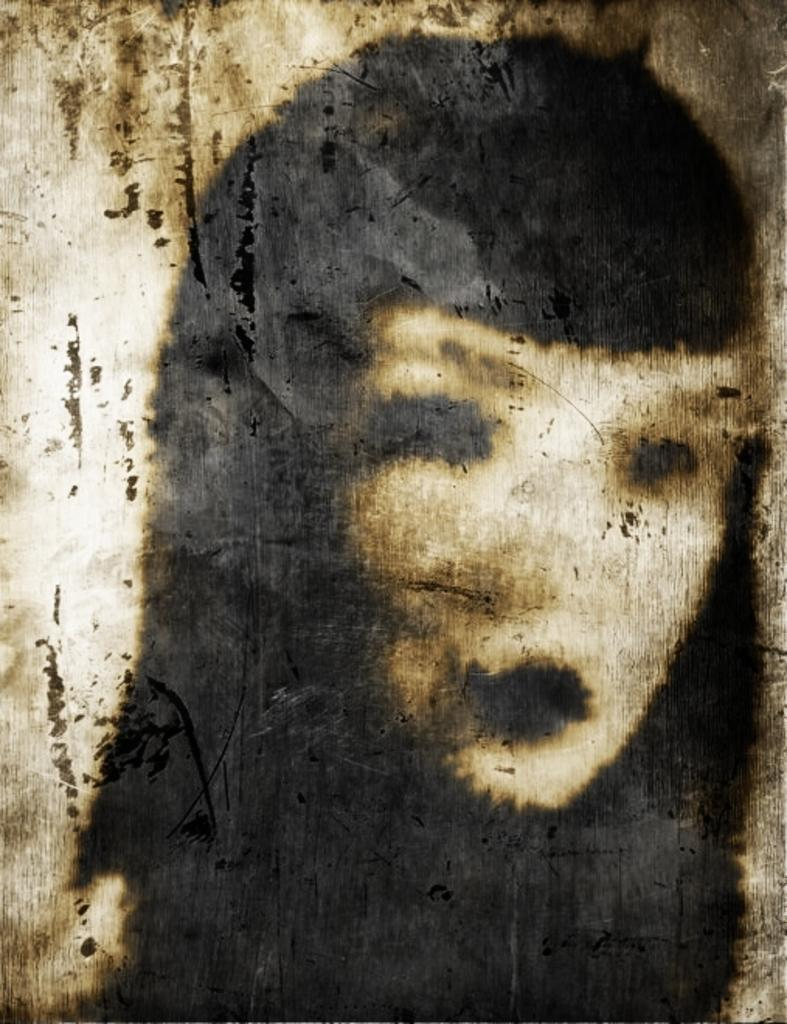What is the main subject of the image? The main subject of the image is a girls poster. Where is the poster located in the image? The poster is in the center of the image. What type of comfort can be seen in the image? There is no comfort visible in the image; it features a girls poster in the center. Is there a letter addressed to the girl in the image? There is no letter present in the image; it only features a girls poster. 